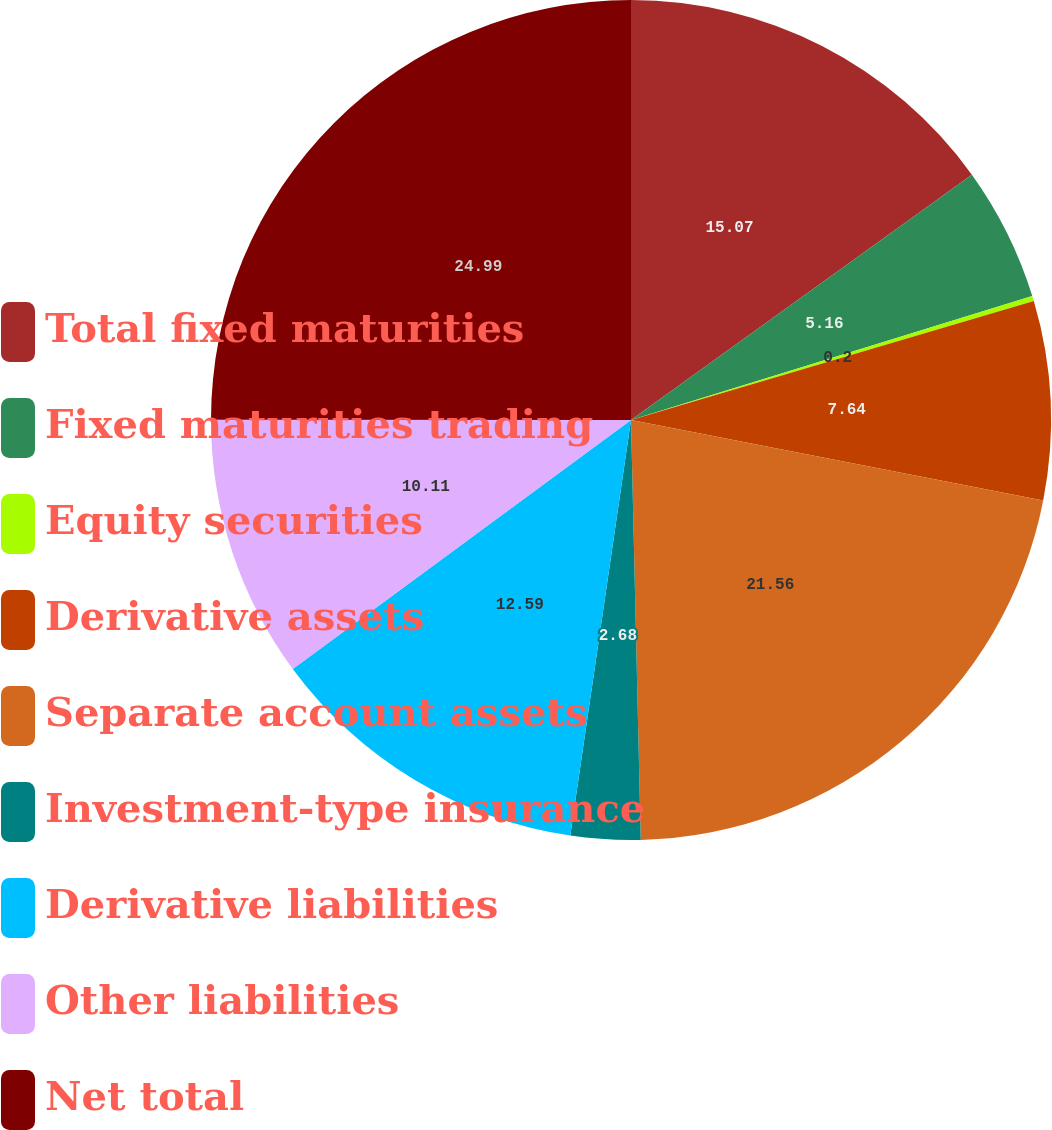<chart> <loc_0><loc_0><loc_500><loc_500><pie_chart><fcel>Total fixed maturities<fcel>Fixed maturities trading<fcel>Equity securities<fcel>Derivative assets<fcel>Separate account assets<fcel>Investment-type insurance<fcel>Derivative liabilities<fcel>Other liabilities<fcel>Net total<nl><fcel>15.07%<fcel>5.16%<fcel>0.2%<fcel>7.64%<fcel>21.56%<fcel>2.68%<fcel>12.59%<fcel>10.11%<fcel>24.99%<nl></chart> 